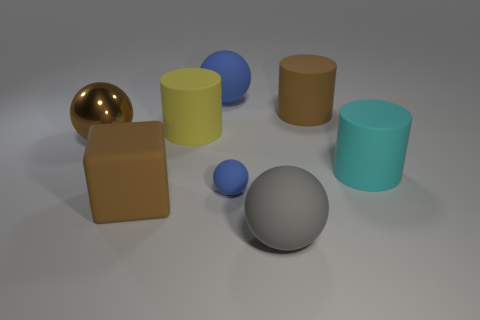Are there any other things that are made of the same material as the brown sphere?
Your answer should be very brief. No. Do the big matte sphere behind the metallic thing and the tiny matte thing that is behind the brown cube have the same color?
Keep it short and to the point. Yes. What number of large balls are both in front of the metallic object and behind the metal ball?
Give a very brief answer. 0. What number of other things are the same shape as the tiny thing?
Your response must be concise. 3. Is the number of balls in front of the cube greater than the number of tiny red rubber objects?
Provide a succinct answer. Yes. What is the color of the matte sphere that is behind the yellow object?
Provide a succinct answer. Blue. What size is the matte block that is the same color as the shiny sphere?
Make the answer very short. Large. What number of rubber objects are either tiny blue spheres or large cyan objects?
Provide a succinct answer. 2. Is there a large rubber cube that is to the left of the large ball to the left of the big blue rubber sphere that is on the left side of the cyan thing?
Make the answer very short. No. What number of large cyan rubber things are left of the big gray rubber ball?
Your response must be concise. 0. 